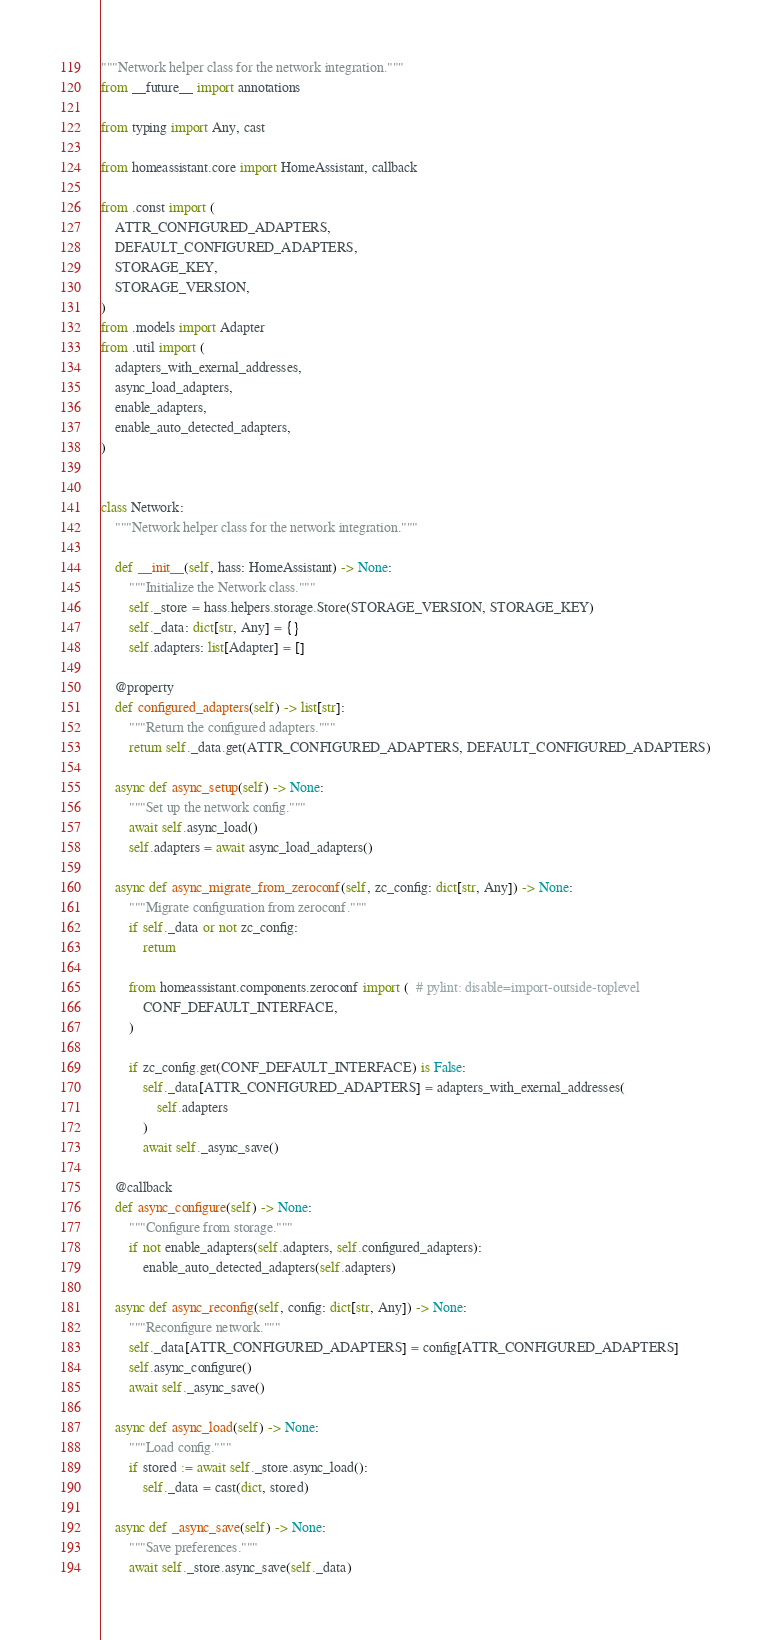Convert code to text. <code><loc_0><loc_0><loc_500><loc_500><_Python_>"""Network helper class for the network integration."""
from __future__ import annotations

from typing import Any, cast

from homeassistant.core import HomeAssistant, callback

from .const import (
    ATTR_CONFIGURED_ADAPTERS,
    DEFAULT_CONFIGURED_ADAPTERS,
    STORAGE_KEY,
    STORAGE_VERSION,
)
from .models import Adapter
from .util import (
    adapters_with_exernal_addresses,
    async_load_adapters,
    enable_adapters,
    enable_auto_detected_adapters,
)


class Network:
    """Network helper class for the network integration."""

    def __init__(self, hass: HomeAssistant) -> None:
        """Initialize the Network class."""
        self._store = hass.helpers.storage.Store(STORAGE_VERSION, STORAGE_KEY)
        self._data: dict[str, Any] = {}
        self.adapters: list[Adapter] = []

    @property
    def configured_adapters(self) -> list[str]:
        """Return the configured adapters."""
        return self._data.get(ATTR_CONFIGURED_ADAPTERS, DEFAULT_CONFIGURED_ADAPTERS)

    async def async_setup(self) -> None:
        """Set up the network config."""
        await self.async_load()
        self.adapters = await async_load_adapters()

    async def async_migrate_from_zeroconf(self, zc_config: dict[str, Any]) -> None:
        """Migrate configuration from zeroconf."""
        if self._data or not zc_config:
            return

        from homeassistant.components.zeroconf import (  # pylint: disable=import-outside-toplevel
            CONF_DEFAULT_INTERFACE,
        )

        if zc_config.get(CONF_DEFAULT_INTERFACE) is False:
            self._data[ATTR_CONFIGURED_ADAPTERS] = adapters_with_exernal_addresses(
                self.adapters
            )
            await self._async_save()

    @callback
    def async_configure(self) -> None:
        """Configure from storage."""
        if not enable_adapters(self.adapters, self.configured_adapters):
            enable_auto_detected_adapters(self.adapters)

    async def async_reconfig(self, config: dict[str, Any]) -> None:
        """Reconfigure network."""
        self._data[ATTR_CONFIGURED_ADAPTERS] = config[ATTR_CONFIGURED_ADAPTERS]
        self.async_configure()
        await self._async_save()

    async def async_load(self) -> None:
        """Load config."""
        if stored := await self._store.async_load():
            self._data = cast(dict, stored)

    async def _async_save(self) -> None:
        """Save preferences."""
        await self._store.async_save(self._data)
</code> 